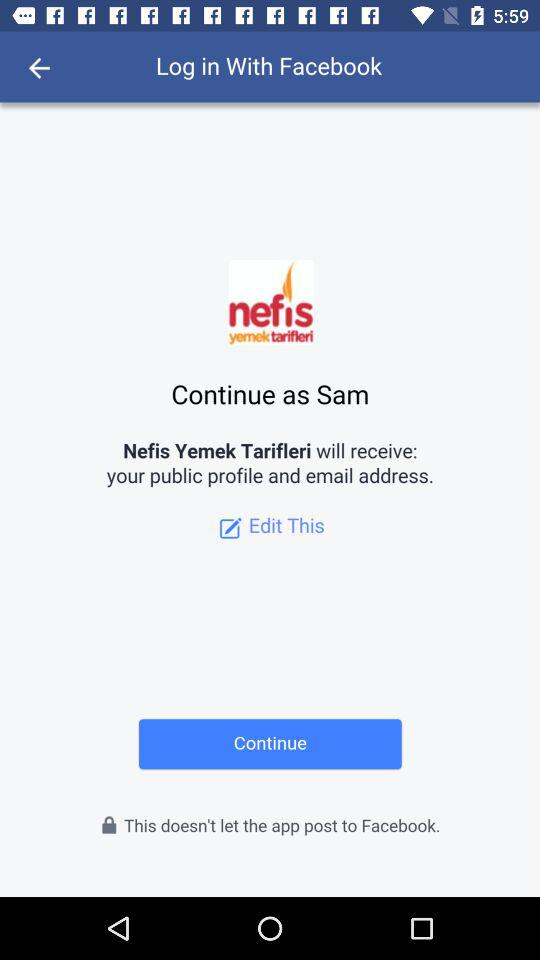What application is asking to log in? The application asking to log in is "Facebook". 